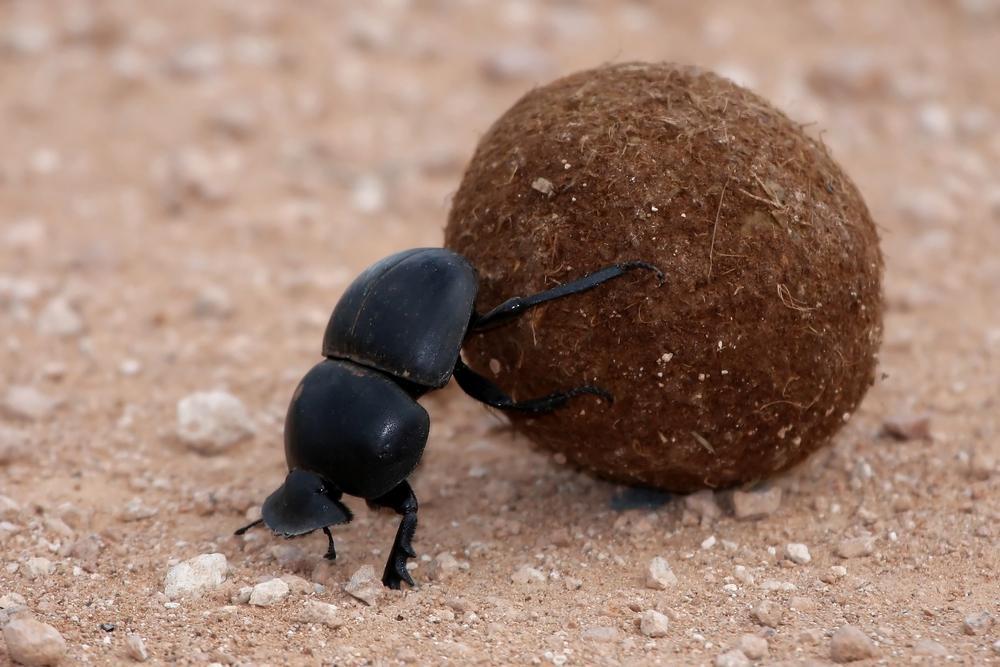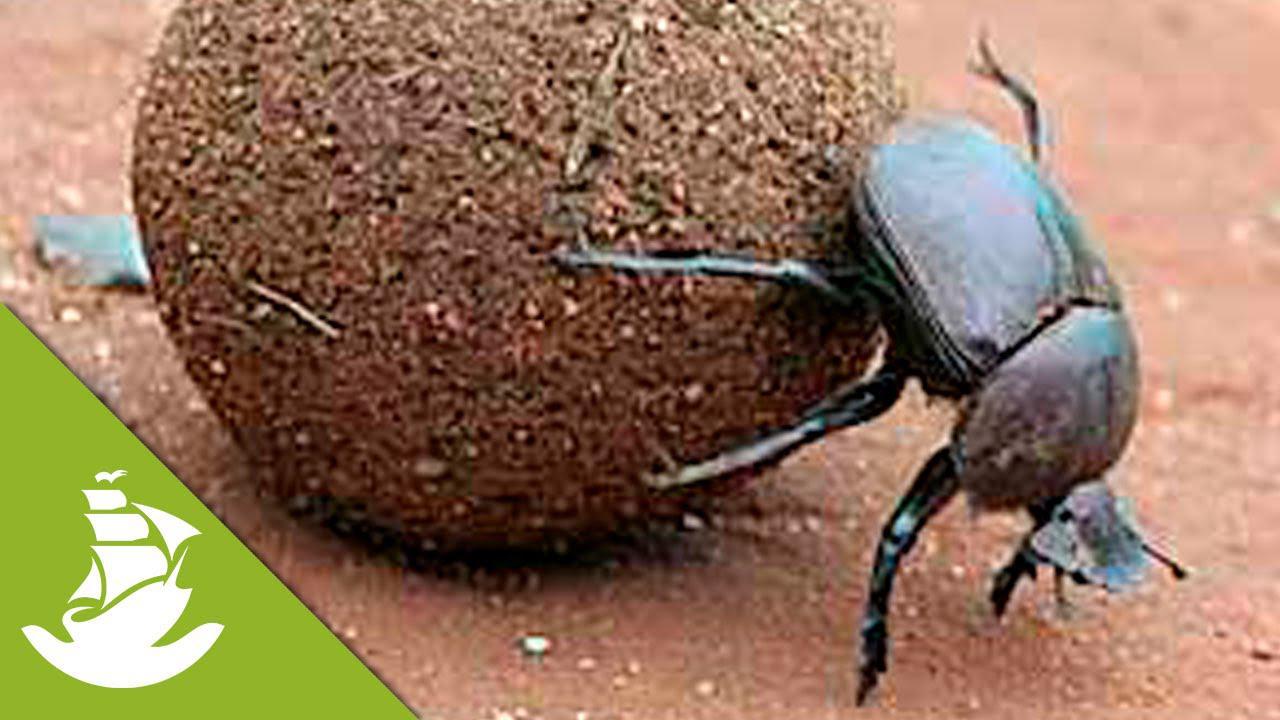The first image is the image on the left, the second image is the image on the right. Given the left and right images, does the statement "The image on the left contains two insects." hold true? Answer yes or no. No. 